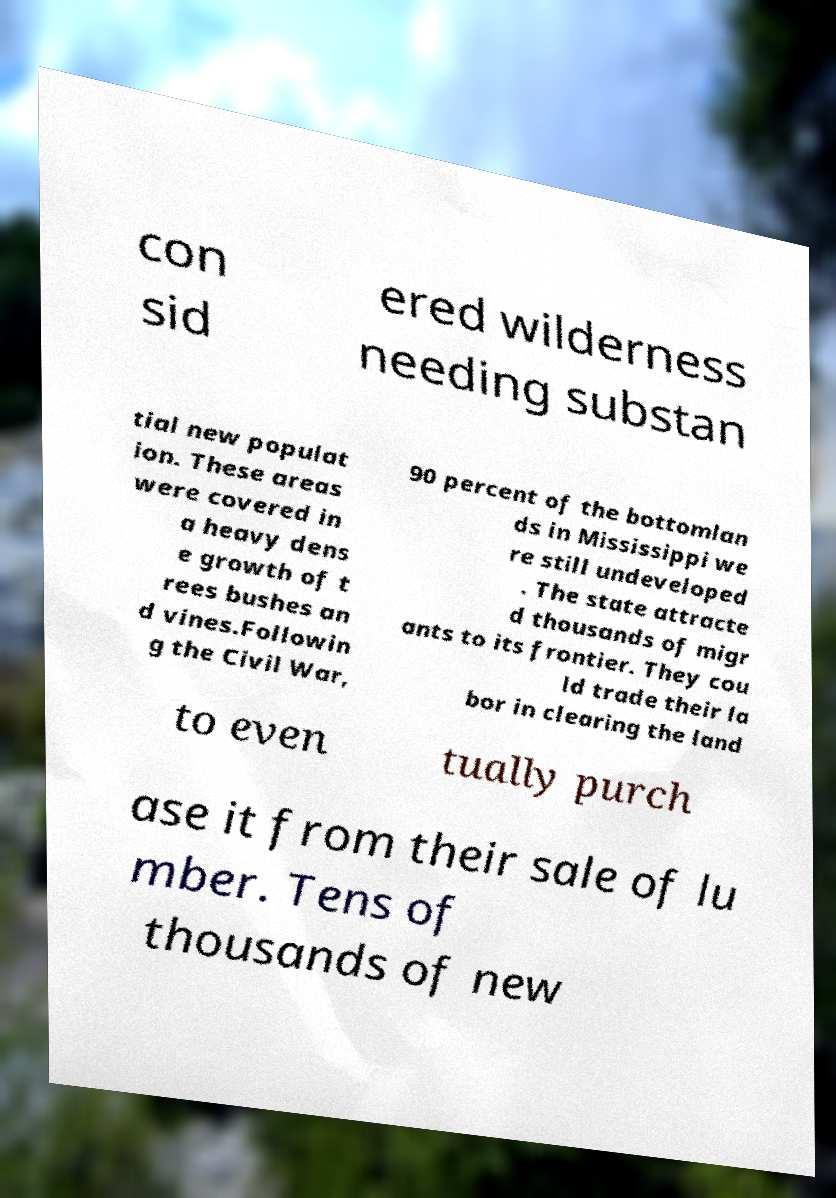I need the written content from this picture converted into text. Can you do that? con sid ered wilderness needing substan tial new populat ion. These areas were covered in a heavy dens e growth of t rees bushes an d vines.Followin g the Civil War, 90 percent of the bottomlan ds in Mississippi we re still undeveloped . The state attracte d thousands of migr ants to its frontier. They cou ld trade their la bor in clearing the land to even tually purch ase it from their sale of lu mber. Tens of thousands of new 